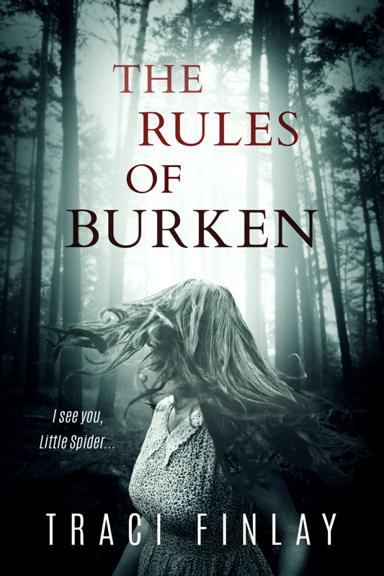What is the title of the book mentioned in the image? The title of the book shown in the image is 'The Rules of Burken,' authored by Traci Finlay. This gripping novel features a hauntingly atmospheric cover that portrays a forest and a figure walking through mist, perfectly encapsulating the book's spine-chilling theme. 